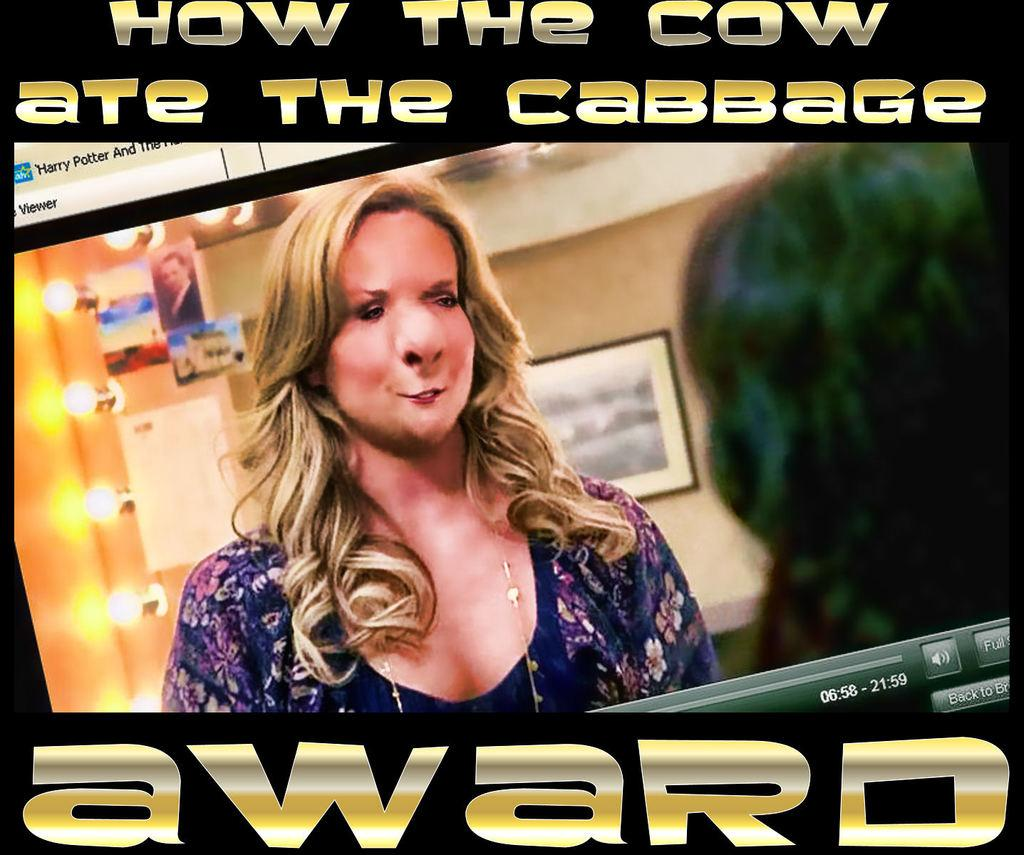What is the main object in the image? There is a screen in the image. What can be seen on the screen? A woman is visible on the screen, along with photos, lights, and text. Is there any other object in the image besides the screen? Yes, there is a frame on the wall in the image. How many corks are visible on the screen in the image? There are no corks visible on the screen in the image. What is the distance between the screen and the frame on the wall? The distance between the screen and the frame on the wall cannot be determined from the image alone. 